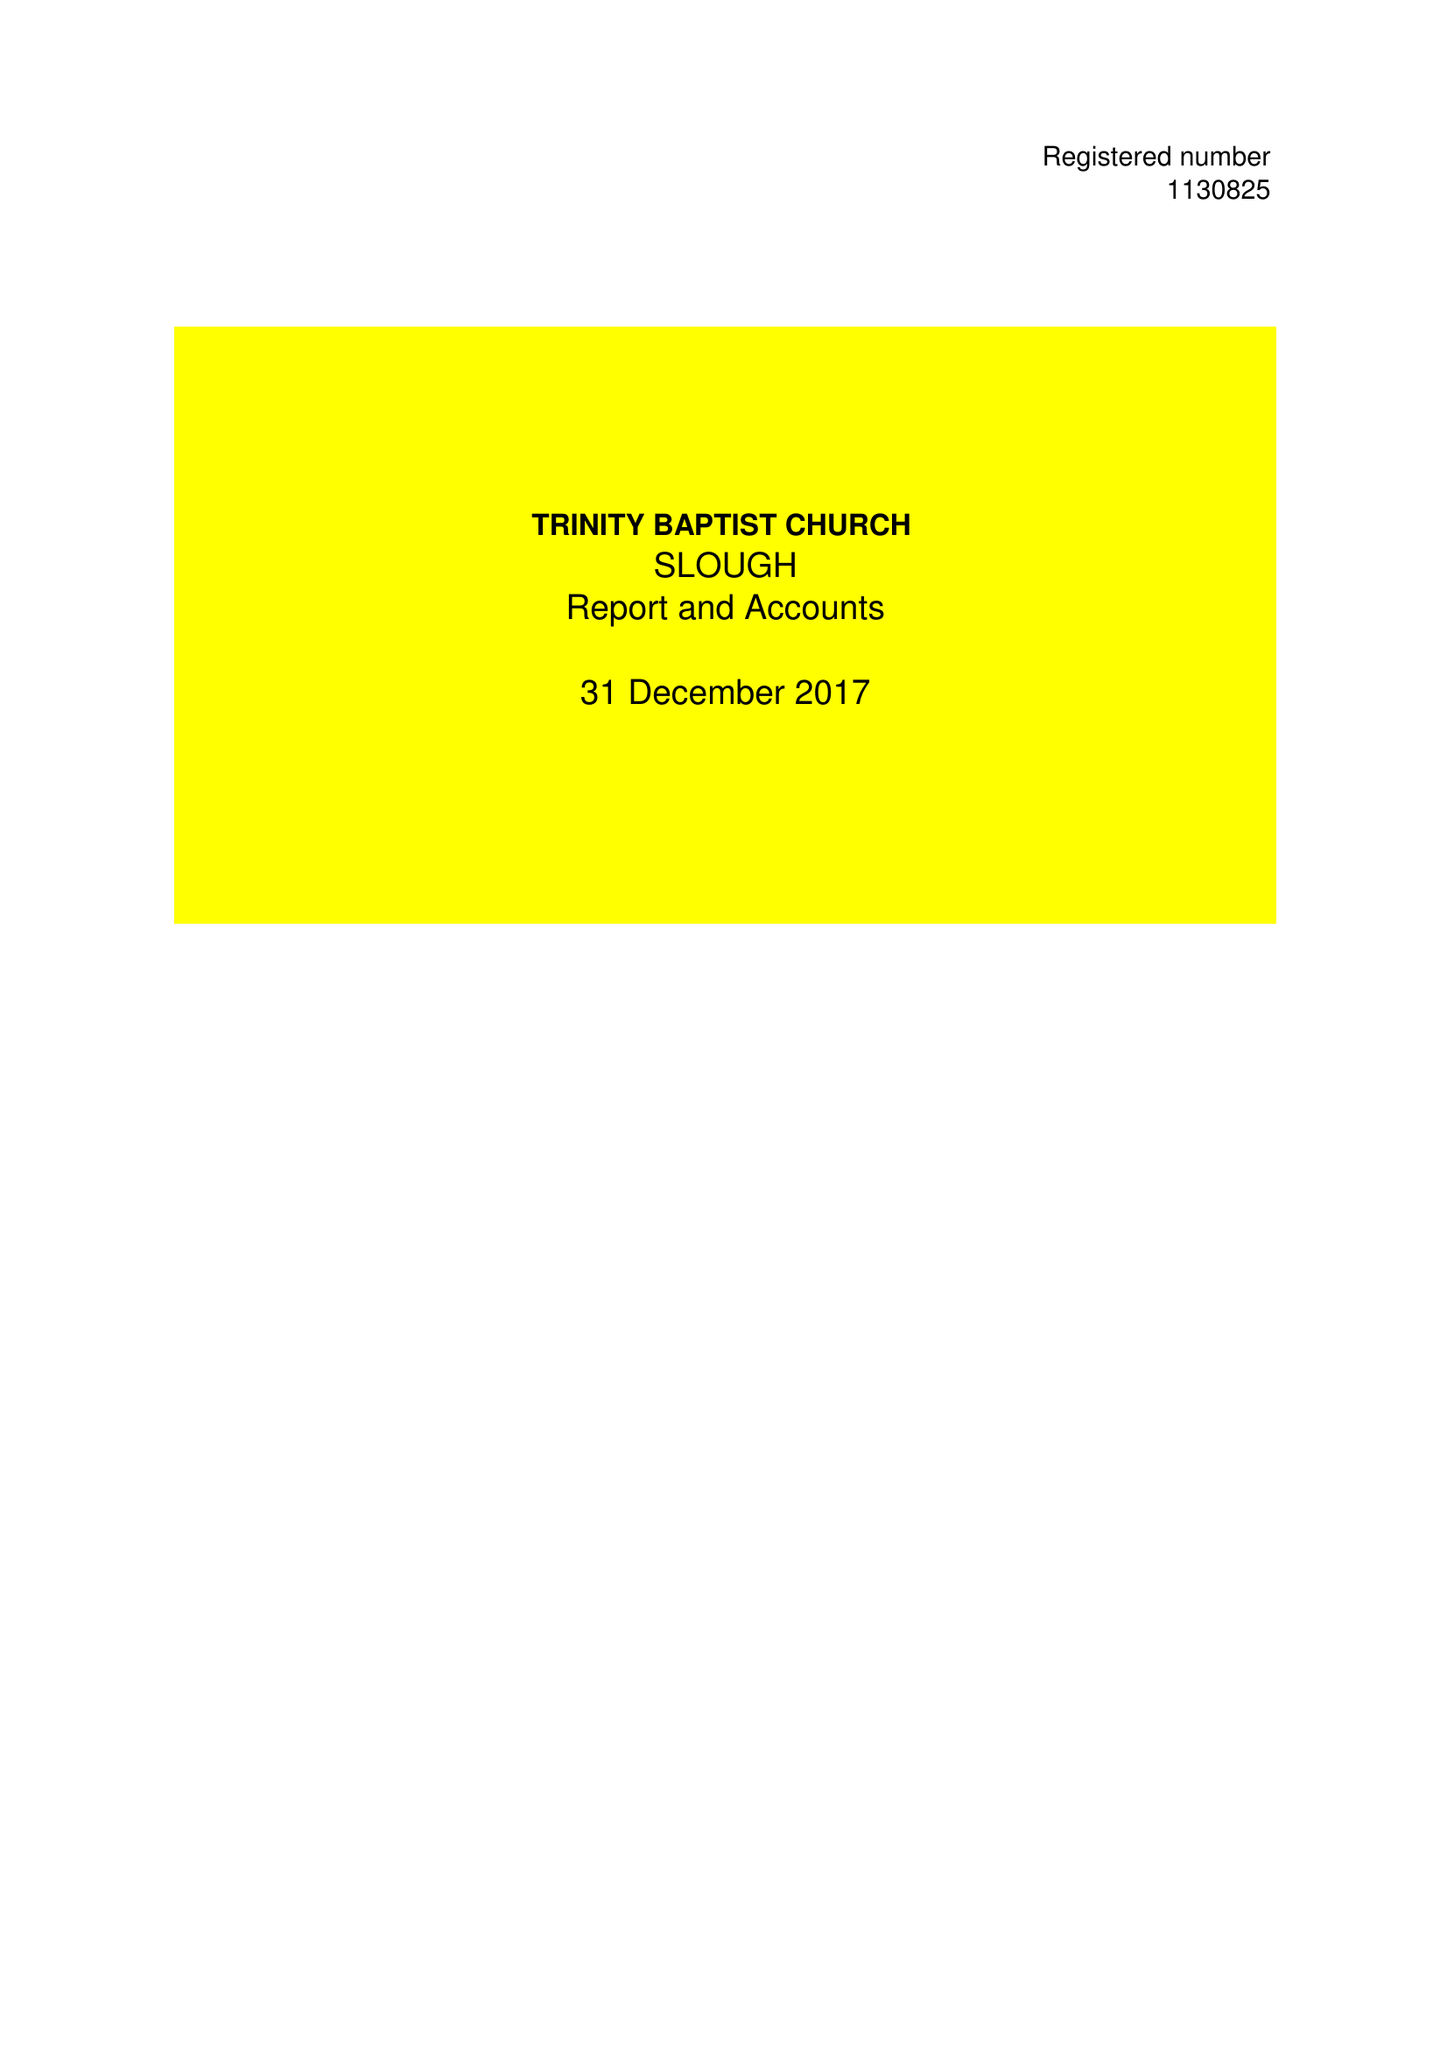What is the value for the address__street_line?
Answer the question using a single word or phrase. 76 GLAMORGAN CLOSE 